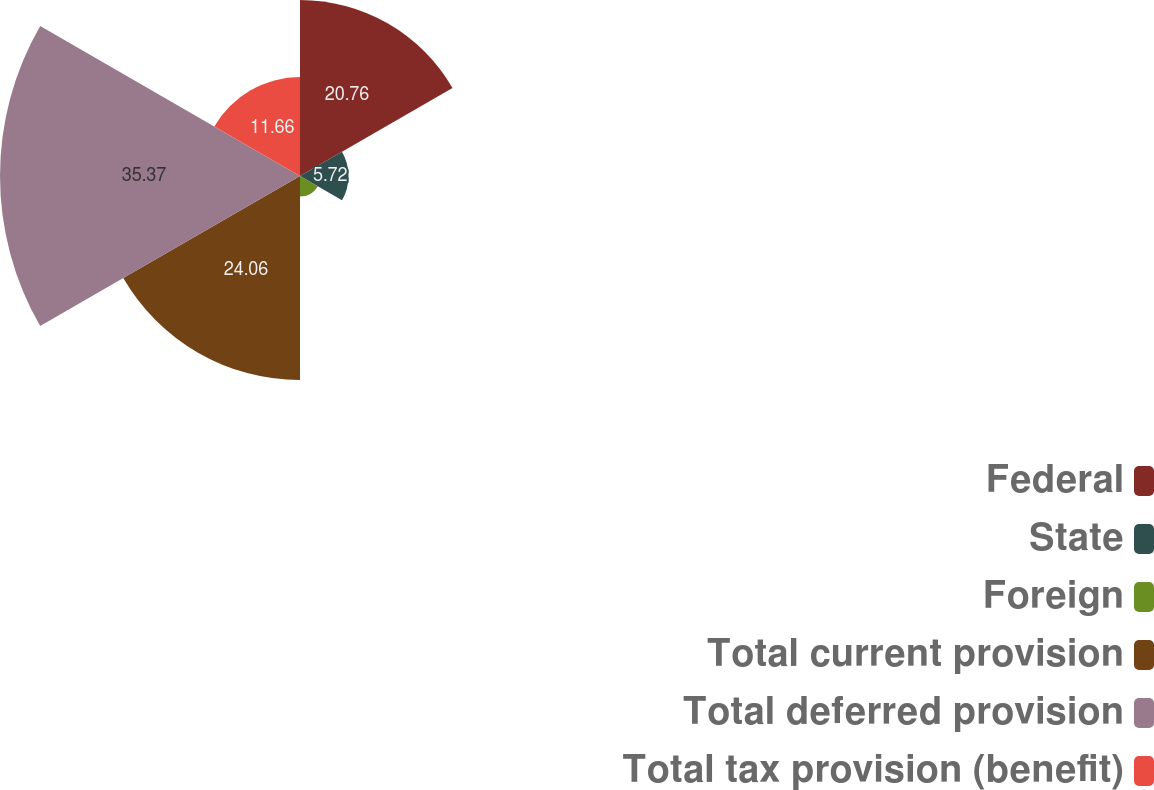Convert chart. <chart><loc_0><loc_0><loc_500><loc_500><pie_chart><fcel>Federal<fcel>State<fcel>Foreign<fcel>Total current provision<fcel>Total deferred provision<fcel>Total tax provision (benefit)<nl><fcel>20.76%<fcel>5.72%<fcel>2.43%<fcel>24.06%<fcel>35.37%<fcel>11.66%<nl></chart> 